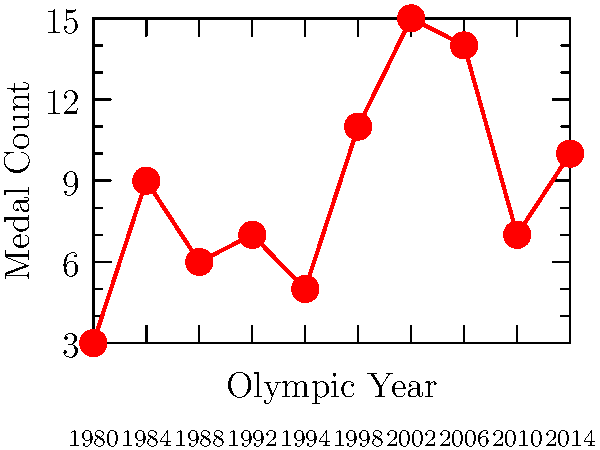Based on the graph showing Swiss Olympic medal counts from 1980 to 2014, in which year did Swiss athletes achieve their highest medal count, and how many medals did they win? To answer this question, we need to follow these steps:

1. Examine the graph carefully, focusing on the red line and data points.
2. Identify the highest point on the graph, which represents the maximum number of medals won.
3. Locate the corresponding year on the x-axis for this highest point.
4. Read the medal count from the y-axis for this data point.

Looking at the graph:

1. The red line shows the trend of Swiss medal counts over the years.
2. The highest point on the graph is clearly visible.
3. This peak corresponds to the year 2002 on the x-axis.
4. The y-axis value for this point is 15 medals.

Therefore, Swiss athletes achieved their highest medal count in 2002, winning 15 medals.
Answer: 2002, 15 medals 